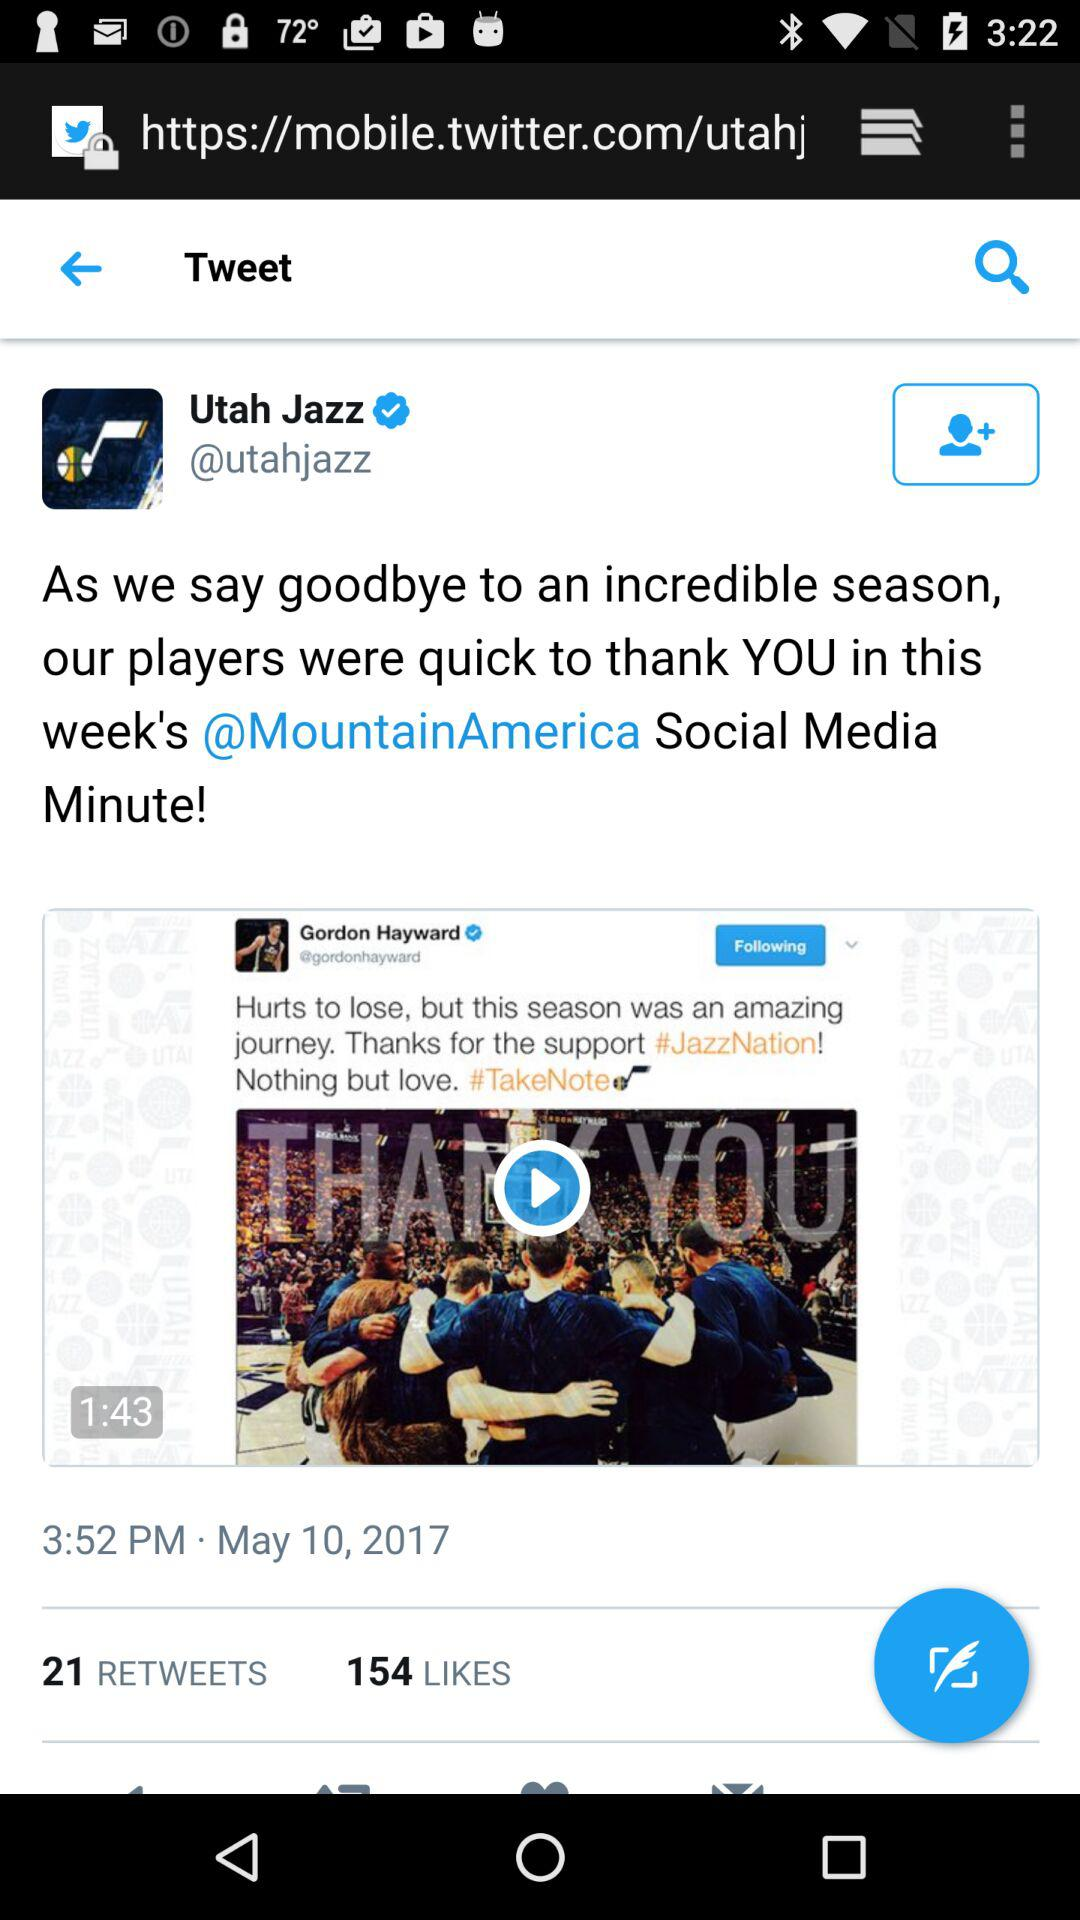How many likes are there on the video? There are 154 likes on the video. 